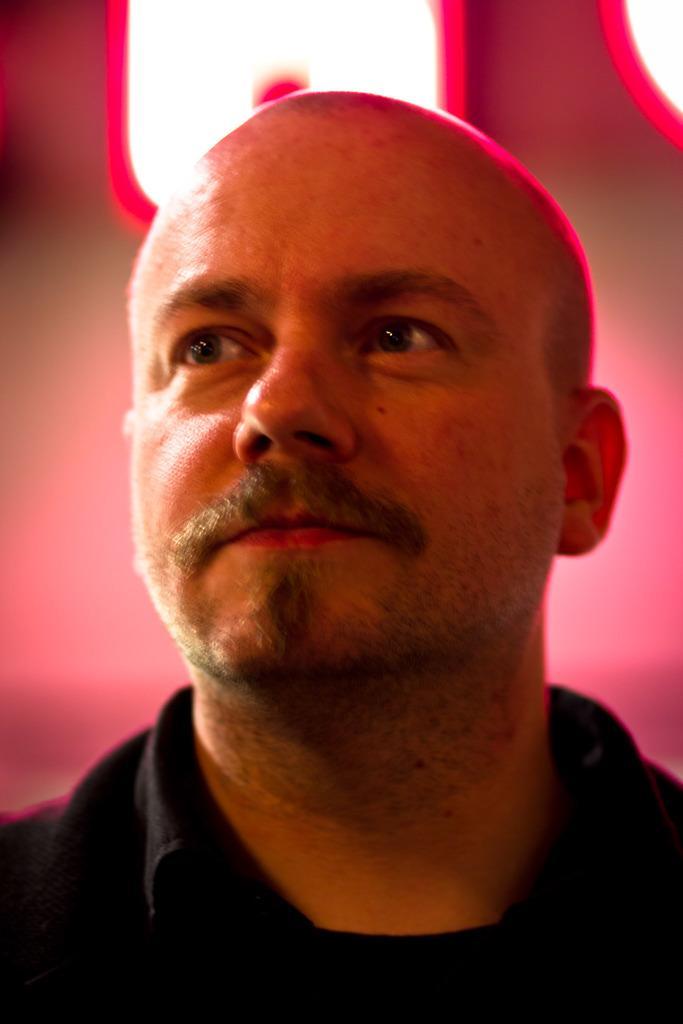Could you give a brief overview of what you see in this image? In this image in the foreground there is one person, and the background is blurred. 